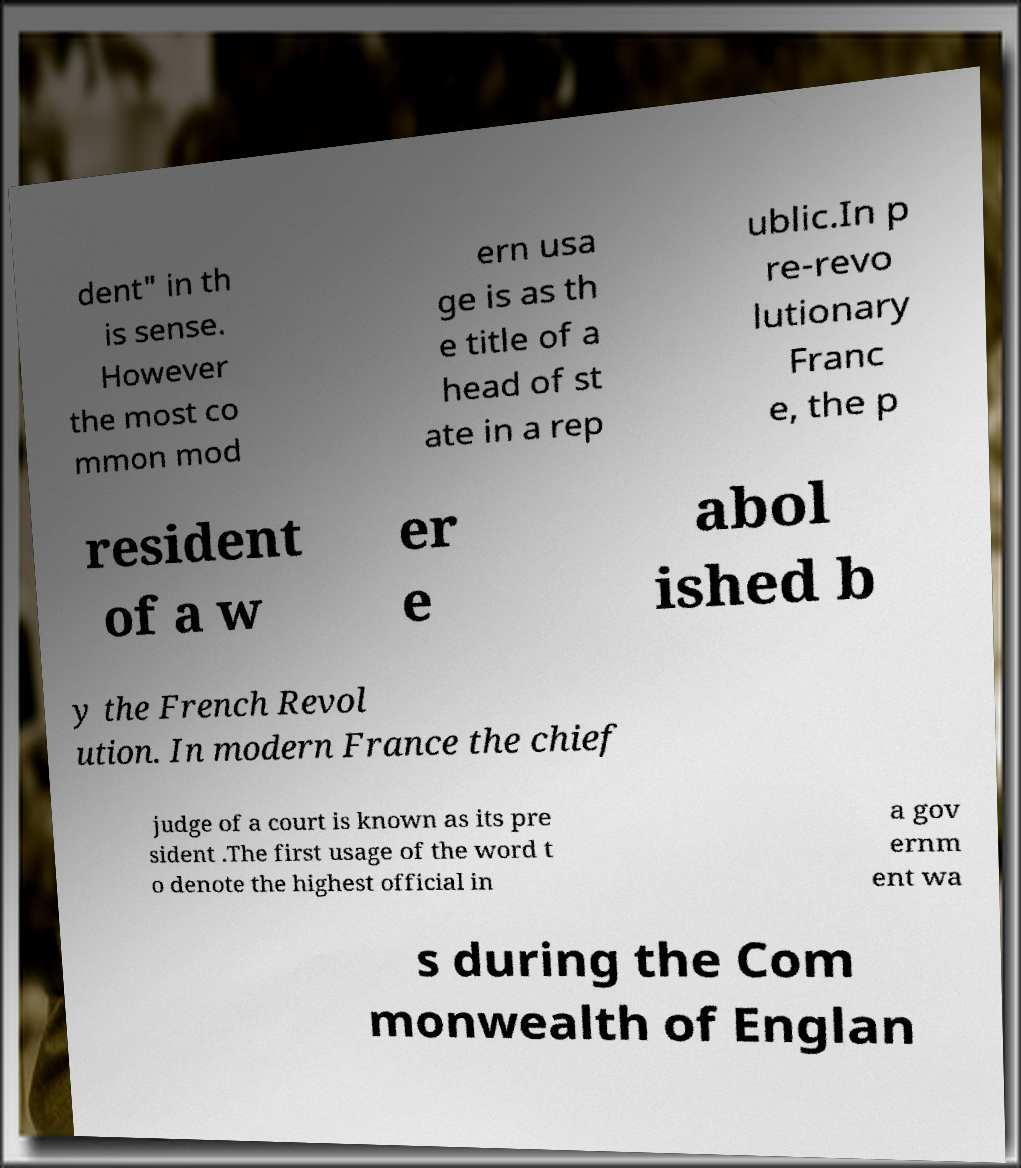Can you accurately transcribe the text from the provided image for me? dent" in th is sense. However the most co mmon mod ern usa ge is as th e title of a head of st ate in a rep ublic.In p re-revo lutionary Franc e, the p resident of a w er e abol ished b y the French Revol ution. In modern France the chief judge of a court is known as its pre sident .The first usage of the word t o denote the highest official in a gov ernm ent wa s during the Com monwealth of Englan 